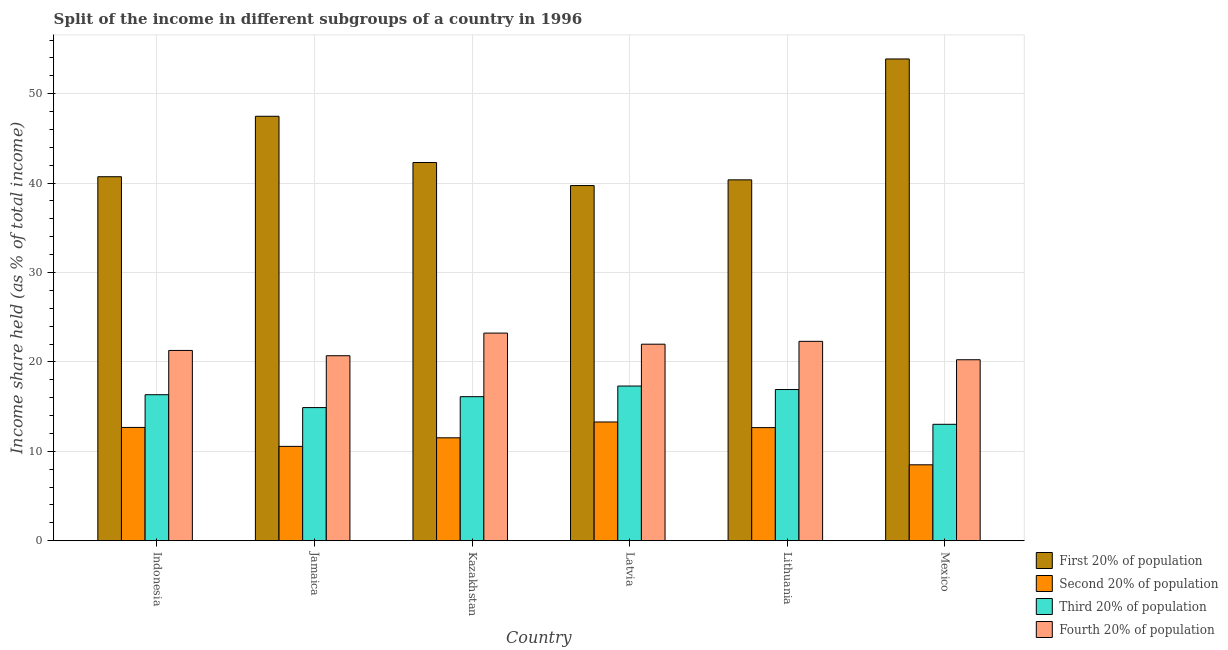How many different coloured bars are there?
Offer a very short reply. 4. Are the number of bars per tick equal to the number of legend labels?
Your response must be concise. Yes. Are the number of bars on each tick of the X-axis equal?
Give a very brief answer. Yes. How many bars are there on the 1st tick from the right?
Give a very brief answer. 4. What is the label of the 3rd group of bars from the left?
Your answer should be compact. Kazakhstan. In how many cases, is the number of bars for a given country not equal to the number of legend labels?
Your response must be concise. 0. What is the share of the income held by third 20% of the population in Indonesia?
Offer a very short reply. 16.33. Across all countries, what is the maximum share of the income held by fourth 20% of the population?
Your answer should be very brief. 23.22. Across all countries, what is the minimum share of the income held by second 20% of the population?
Keep it short and to the point. 8.49. In which country was the share of the income held by fourth 20% of the population maximum?
Ensure brevity in your answer.  Kazakhstan. In which country was the share of the income held by first 20% of the population minimum?
Make the answer very short. Latvia. What is the total share of the income held by fourth 20% of the population in the graph?
Offer a terse response. 129.71. What is the difference between the share of the income held by second 20% of the population in Kazakhstan and that in Mexico?
Your answer should be compact. 3.02. What is the difference between the share of the income held by first 20% of the population in Lithuania and the share of the income held by second 20% of the population in Jamaica?
Give a very brief answer. 29.81. What is the average share of the income held by first 20% of the population per country?
Provide a short and direct response. 44.07. What is the difference between the share of the income held by second 20% of the population and share of the income held by first 20% of the population in Lithuania?
Offer a very short reply. -27.71. In how many countries, is the share of the income held by first 20% of the population greater than 46 %?
Your answer should be compact. 2. What is the ratio of the share of the income held by third 20% of the population in Jamaica to that in Lithuania?
Ensure brevity in your answer.  0.88. What is the difference between the highest and the second highest share of the income held by second 20% of the population?
Make the answer very short. 0.61. What is the difference between the highest and the lowest share of the income held by first 20% of the population?
Your answer should be very brief. 14.16. In how many countries, is the share of the income held by fourth 20% of the population greater than the average share of the income held by fourth 20% of the population taken over all countries?
Your answer should be very brief. 3. Is the sum of the share of the income held by fourth 20% of the population in Latvia and Mexico greater than the maximum share of the income held by first 20% of the population across all countries?
Your response must be concise. No. Is it the case that in every country, the sum of the share of the income held by third 20% of the population and share of the income held by fourth 20% of the population is greater than the sum of share of the income held by first 20% of the population and share of the income held by second 20% of the population?
Ensure brevity in your answer.  No. What does the 1st bar from the left in Latvia represents?
Provide a short and direct response. First 20% of population. What does the 4th bar from the right in Jamaica represents?
Ensure brevity in your answer.  First 20% of population. Are all the bars in the graph horizontal?
Provide a succinct answer. No. How many countries are there in the graph?
Offer a very short reply. 6. What is the difference between two consecutive major ticks on the Y-axis?
Make the answer very short. 10. Are the values on the major ticks of Y-axis written in scientific E-notation?
Provide a succinct answer. No. Does the graph contain any zero values?
Keep it short and to the point. No. Where does the legend appear in the graph?
Offer a terse response. Bottom right. What is the title of the graph?
Your answer should be compact. Split of the income in different subgroups of a country in 1996. What is the label or title of the Y-axis?
Your answer should be very brief. Income share held (as % of total income). What is the Income share held (as % of total income) of First 20% of population in Indonesia?
Offer a very short reply. 40.71. What is the Income share held (as % of total income) of Second 20% of population in Indonesia?
Give a very brief answer. 12.67. What is the Income share held (as % of total income) of Third 20% of population in Indonesia?
Give a very brief answer. 16.33. What is the Income share held (as % of total income) in Fourth 20% of population in Indonesia?
Keep it short and to the point. 21.28. What is the Income share held (as % of total income) of First 20% of population in Jamaica?
Your response must be concise. 47.47. What is the Income share held (as % of total income) of Second 20% of population in Jamaica?
Your answer should be compact. 10.55. What is the Income share held (as % of total income) of Third 20% of population in Jamaica?
Provide a succinct answer. 14.89. What is the Income share held (as % of total income) of Fourth 20% of population in Jamaica?
Provide a short and direct response. 20.69. What is the Income share held (as % of total income) in First 20% of population in Kazakhstan?
Give a very brief answer. 42.3. What is the Income share held (as % of total income) in Second 20% of population in Kazakhstan?
Offer a terse response. 11.51. What is the Income share held (as % of total income) in Third 20% of population in Kazakhstan?
Your response must be concise. 16.11. What is the Income share held (as % of total income) in Fourth 20% of population in Kazakhstan?
Provide a short and direct response. 23.22. What is the Income share held (as % of total income) in First 20% of population in Latvia?
Your answer should be very brief. 39.72. What is the Income share held (as % of total income) in Second 20% of population in Latvia?
Offer a terse response. 13.28. What is the Income share held (as % of total income) of Third 20% of population in Latvia?
Give a very brief answer. 17.3. What is the Income share held (as % of total income) of Fourth 20% of population in Latvia?
Offer a terse response. 21.98. What is the Income share held (as % of total income) of First 20% of population in Lithuania?
Make the answer very short. 40.36. What is the Income share held (as % of total income) in Second 20% of population in Lithuania?
Ensure brevity in your answer.  12.65. What is the Income share held (as % of total income) of Third 20% of population in Lithuania?
Offer a terse response. 16.91. What is the Income share held (as % of total income) in Fourth 20% of population in Lithuania?
Offer a very short reply. 22.3. What is the Income share held (as % of total income) of First 20% of population in Mexico?
Your response must be concise. 53.88. What is the Income share held (as % of total income) in Second 20% of population in Mexico?
Your answer should be very brief. 8.49. What is the Income share held (as % of total income) in Third 20% of population in Mexico?
Provide a short and direct response. 13.02. What is the Income share held (as % of total income) of Fourth 20% of population in Mexico?
Provide a succinct answer. 20.24. Across all countries, what is the maximum Income share held (as % of total income) of First 20% of population?
Make the answer very short. 53.88. Across all countries, what is the maximum Income share held (as % of total income) in Second 20% of population?
Your response must be concise. 13.28. Across all countries, what is the maximum Income share held (as % of total income) in Fourth 20% of population?
Offer a very short reply. 23.22. Across all countries, what is the minimum Income share held (as % of total income) in First 20% of population?
Make the answer very short. 39.72. Across all countries, what is the minimum Income share held (as % of total income) of Second 20% of population?
Offer a very short reply. 8.49. Across all countries, what is the minimum Income share held (as % of total income) of Third 20% of population?
Your response must be concise. 13.02. Across all countries, what is the minimum Income share held (as % of total income) of Fourth 20% of population?
Your response must be concise. 20.24. What is the total Income share held (as % of total income) in First 20% of population in the graph?
Your answer should be compact. 264.44. What is the total Income share held (as % of total income) in Second 20% of population in the graph?
Keep it short and to the point. 69.15. What is the total Income share held (as % of total income) in Third 20% of population in the graph?
Make the answer very short. 94.56. What is the total Income share held (as % of total income) of Fourth 20% of population in the graph?
Your answer should be compact. 129.71. What is the difference between the Income share held (as % of total income) in First 20% of population in Indonesia and that in Jamaica?
Provide a succinct answer. -6.76. What is the difference between the Income share held (as % of total income) in Second 20% of population in Indonesia and that in Jamaica?
Ensure brevity in your answer.  2.12. What is the difference between the Income share held (as % of total income) of Third 20% of population in Indonesia and that in Jamaica?
Offer a very short reply. 1.44. What is the difference between the Income share held (as % of total income) in Fourth 20% of population in Indonesia and that in Jamaica?
Keep it short and to the point. 0.59. What is the difference between the Income share held (as % of total income) in First 20% of population in Indonesia and that in Kazakhstan?
Provide a short and direct response. -1.59. What is the difference between the Income share held (as % of total income) of Second 20% of population in Indonesia and that in Kazakhstan?
Your response must be concise. 1.16. What is the difference between the Income share held (as % of total income) of Third 20% of population in Indonesia and that in Kazakhstan?
Offer a terse response. 0.22. What is the difference between the Income share held (as % of total income) of Fourth 20% of population in Indonesia and that in Kazakhstan?
Provide a succinct answer. -1.94. What is the difference between the Income share held (as % of total income) in First 20% of population in Indonesia and that in Latvia?
Offer a terse response. 0.99. What is the difference between the Income share held (as % of total income) in Second 20% of population in Indonesia and that in Latvia?
Keep it short and to the point. -0.61. What is the difference between the Income share held (as % of total income) of Third 20% of population in Indonesia and that in Latvia?
Offer a very short reply. -0.97. What is the difference between the Income share held (as % of total income) of Fourth 20% of population in Indonesia and that in Latvia?
Your answer should be very brief. -0.7. What is the difference between the Income share held (as % of total income) of First 20% of population in Indonesia and that in Lithuania?
Offer a very short reply. 0.35. What is the difference between the Income share held (as % of total income) in Second 20% of population in Indonesia and that in Lithuania?
Your response must be concise. 0.02. What is the difference between the Income share held (as % of total income) of Third 20% of population in Indonesia and that in Lithuania?
Offer a very short reply. -0.58. What is the difference between the Income share held (as % of total income) in Fourth 20% of population in Indonesia and that in Lithuania?
Provide a succinct answer. -1.02. What is the difference between the Income share held (as % of total income) in First 20% of population in Indonesia and that in Mexico?
Your response must be concise. -13.17. What is the difference between the Income share held (as % of total income) of Second 20% of population in Indonesia and that in Mexico?
Offer a very short reply. 4.18. What is the difference between the Income share held (as % of total income) in Third 20% of population in Indonesia and that in Mexico?
Make the answer very short. 3.31. What is the difference between the Income share held (as % of total income) in Fourth 20% of population in Indonesia and that in Mexico?
Ensure brevity in your answer.  1.04. What is the difference between the Income share held (as % of total income) of First 20% of population in Jamaica and that in Kazakhstan?
Your answer should be compact. 5.17. What is the difference between the Income share held (as % of total income) of Second 20% of population in Jamaica and that in Kazakhstan?
Keep it short and to the point. -0.96. What is the difference between the Income share held (as % of total income) of Third 20% of population in Jamaica and that in Kazakhstan?
Your answer should be very brief. -1.22. What is the difference between the Income share held (as % of total income) in Fourth 20% of population in Jamaica and that in Kazakhstan?
Make the answer very short. -2.53. What is the difference between the Income share held (as % of total income) of First 20% of population in Jamaica and that in Latvia?
Provide a succinct answer. 7.75. What is the difference between the Income share held (as % of total income) of Second 20% of population in Jamaica and that in Latvia?
Offer a terse response. -2.73. What is the difference between the Income share held (as % of total income) of Third 20% of population in Jamaica and that in Latvia?
Your answer should be very brief. -2.41. What is the difference between the Income share held (as % of total income) of Fourth 20% of population in Jamaica and that in Latvia?
Offer a very short reply. -1.29. What is the difference between the Income share held (as % of total income) in First 20% of population in Jamaica and that in Lithuania?
Your answer should be compact. 7.11. What is the difference between the Income share held (as % of total income) in Third 20% of population in Jamaica and that in Lithuania?
Your answer should be very brief. -2.02. What is the difference between the Income share held (as % of total income) of Fourth 20% of population in Jamaica and that in Lithuania?
Make the answer very short. -1.61. What is the difference between the Income share held (as % of total income) of First 20% of population in Jamaica and that in Mexico?
Make the answer very short. -6.41. What is the difference between the Income share held (as % of total income) in Second 20% of population in Jamaica and that in Mexico?
Give a very brief answer. 2.06. What is the difference between the Income share held (as % of total income) of Third 20% of population in Jamaica and that in Mexico?
Your answer should be very brief. 1.87. What is the difference between the Income share held (as % of total income) in Fourth 20% of population in Jamaica and that in Mexico?
Offer a very short reply. 0.45. What is the difference between the Income share held (as % of total income) in First 20% of population in Kazakhstan and that in Latvia?
Keep it short and to the point. 2.58. What is the difference between the Income share held (as % of total income) in Second 20% of population in Kazakhstan and that in Latvia?
Keep it short and to the point. -1.77. What is the difference between the Income share held (as % of total income) in Third 20% of population in Kazakhstan and that in Latvia?
Offer a very short reply. -1.19. What is the difference between the Income share held (as % of total income) of Fourth 20% of population in Kazakhstan and that in Latvia?
Offer a terse response. 1.24. What is the difference between the Income share held (as % of total income) in First 20% of population in Kazakhstan and that in Lithuania?
Give a very brief answer. 1.94. What is the difference between the Income share held (as % of total income) in Second 20% of population in Kazakhstan and that in Lithuania?
Give a very brief answer. -1.14. What is the difference between the Income share held (as % of total income) in Fourth 20% of population in Kazakhstan and that in Lithuania?
Ensure brevity in your answer.  0.92. What is the difference between the Income share held (as % of total income) of First 20% of population in Kazakhstan and that in Mexico?
Keep it short and to the point. -11.58. What is the difference between the Income share held (as % of total income) in Second 20% of population in Kazakhstan and that in Mexico?
Give a very brief answer. 3.02. What is the difference between the Income share held (as % of total income) in Third 20% of population in Kazakhstan and that in Mexico?
Give a very brief answer. 3.09. What is the difference between the Income share held (as % of total income) in Fourth 20% of population in Kazakhstan and that in Mexico?
Make the answer very short. 2.98. What is the difference between the Income share held (as % of total income) of First 20% of population in Latvia and that in Lithuania?
Your response must be concise. -0.64. What is the difference between the Income share held (as % of total income) of Second 20% of population in Latvia and that in Lithuania?
Make the answer very short. 0.63. What is the difference between the Income share held (as % of total income) of Third 20% of population in Latvia and that in Lithuania?
Provide a succinct answer. 0.39. What is the difference between the Income share held (as % of total income) of Fourth 20% of population in Latvia and that in Lithuania?
Ensure brevity in your answer.  -0.32. What is the difference between the Income share held (as % of total income) in First 20% of population in Latvia and that in Mexico?
Your answer should be compact. -14.16. What is the difference between the Income share held (as % of total income) of Second 20% of population in Latvia and that in Mexico?
Your answer should be very brief. 4.79. What is the difference between the Income share held (as % of total income) in Third 20% of population in Latvia and that in Mexico?
Offer a terse response. 4.28. What is the difference between the Income share held (as % of total income) in Fourth 20% of population in Latvia and that in Mexico?
Offer a very short reply. 1.74. What is the difference between the Income share held (as % of total income) in First 20% of population in Lithuania and that in Mexico?
Your response must be concise. -13.52. What is the difference between the Income share held (as % of total income) in Second 20% of population in Lithuania and that in Mexico?
Give a very brief answer. 4.16. What is the difference between the Income share held (as % of total income) in Third 20% of population in Lithuania and that in Mexico?
Your answer should be very brief. 3.89. What is the difference between the Income share held (as % of total income) of Fourth 20% of population in Lithuania and that in Mexico?
Ensure brevity in your answer.  2.06. What is the difference between the Income share held (as % of total income) in First 20% of population in Indonesia and the Income share held (as % of total income) in Second 20% of population in Jamaica?
Ensure brevity in your answer.  30.16. What is the difference between the Income share held (as % of total income) of First 20% of population in Indonesia and the Income share held (as % of total income) of Third 20% of population in Jamaica?
Keep it short and to the point. 25.82. What is the difference between the Income share held (as % of total income) of First 20% of population in Indonesia and the Income share held (as % of total income) of Fourth 20% of population in Jamaica?
Ensure brevity in your answer.  20.02. What is the difference between the Income share held (as % of total income) in Second 20% of population in Indonesia and the Income share held (as % of total income) in Third 20% of population in Jamaica?
Your answer should be compact. -2.22. What is the difference between the Income share held (as % of total income) in Second 20% of population in Indonesia and the Income share held (as % of total income) in Fourth 20% of population in Jamaica?
Your response must be concise. -8.02. What is the difference between the Income share held (as % of total income) of Third 20% of population in Indonesia and the Income share held (as % of total income) of Fourth 20% of population in Jamaica?
Your answer should be very brief. -4.36. What is the difference between the Income share held (as % of total income) of First 20% of population in Indonesia and the Income share held (as % of total income) of Second 20% of population in Kazakhstan?
Your answer should be compact. 29.2. What is the difference between the Income share held (as % of total income) of First 20% of population in Indonesia and the Income share held (as % of total income) of Third 20% of population in Kazakhstan?
Offer a very short reply. 24.6. What is the difference between the Income share held (as % of total income) of First 20% of population in Indonesia and the Income share held (as % of total income) of Fourth 20% of population in Kazakhstan?
Give a very brief answer. 17.49. What is the difference between the Income share held (as % of total income) in Second 20% of population in Indonesia and the Income share held (as % of total income) in Third 20% of population in Kazakhstan?
Make the answer very short. -3.44. What is the difference between the Income share held (as % of total income) in Second 20% of population in Indonesia and the Income share held (as % of total income) in Fourth 20% of population in Kazakhstan?
Keep it short and to the point. -10.55. What is the difference between the Income share held (as % of total income) of Third 20% of population in Indonesia and the Income share held (as % of total income) of Fourth 20% of population in Kazakhstan?
Provide a short and direct response. -6.89. What is the difference between the Income share held (as % of total income) of First 20% of population in Indonesia and the Income share held (as % of total income) of Second 20% of population in Latvia?
Ensure brevity in your answer.  27.43. What is the difference between the Income share held (as % of total income) of First 20% of population in Indonesia and the Income share held (as % of total income) of Third 20% of population in Latvia?
Your answer should be very brief. 23.41. What is the difference between the Income share held (as % of total income) in First 20% of population in Indonesia and the Income share held (as % of total income) in Fourth 20% of population in Latvia?
Ensure brevity in your answer.  18.73. What is the difference between the Income share held (as % of total income) of Second 20% of population in Indonesia and the Income share held (as % of total income) of Third 20% of population in Latvia?
Your answer should be compact. -4.63. What is the difference between the Income share held (as % of total income) of Second 20% of population in Indonesia and the Income share held (as % of total income) of Fourth 20% of population in Latvia?
Your response must be concise. -9.31. What is the difference between the Income share held (as % of total income) in Third 20% of population in Indonesia and the Income share held (as % of total income) in Fourth 20% of population in Latvia?
Ensure brevity in your answer.  -5.65. What is the difference between the Income share held (as % of total income) in First 20% of population in Indonesia and the Income share held (as % of total income) in Second 20% of population in Lithuania?
Your answer should be compact. 28.06. What is the difference between the Income share held (as % of total income) of First 20% of population in Indonesia and the Income share held (as % of total income) of Third 20% of population in Lithuania?
Provide a succinct answer. 23.8. What is the difference between the Income share held (as % of total income) of First 20% of population in Indonesia and the Income share held (as % of total income) of Fourth 20% of population in Lithuania?
Your response must be concise. 18.41. What is the difference between the Income share held (as % of total income) in Second 20% of population in Indonesia and the Income share held (as % of total income) in Third 20% of population in Lithuania?
Provide a short and direct response. -4.24. What is the difference between the Income share held (as % of total income) in Second 20% of population in Indonesia and the Income share held (as % of total income) in Fourth 20% of population in Lithuania?
Provide a succinct answer. -9.63. What is the difference between the Income share held (as % of total income) in Third 20% of population in Indonesia and the Income share held (as % of total income) in Fourth 20% of population in Lithuania?
Give a very brief answer. -5.97. What is the difference between the Income share held (as % of total income) of First 20% of population in Indonesia and the Income share held (as % of total income) of Second 20% of population in Mexico?
Offer a terse response. 32.22. What is the difference between the Income share held (as % of total income) of First 20% of population in Indonesia and the Income share held (as % of total income) of Third 20% of population in Mexico?
Provide a short and direct response. 27.69. What is the difference between the Income share held (as % of total income) of First 20% of population in Indonesia and the Income share held (as % of total income) of Fourth 20% of population in Mexico?
Your response must be concise. 20.47. What is the difference between the Income share held (as % of total income) in Second 20% of population in Indonesia and the Income share held (as % of total income) in Third 20% of population in Mexico?
Keep it short and to the point. -0.35. What is the difference between the Income share held (as % of total income) of Second 20% of population in Indonesia and the Income share held (as % of total income) of Fourth 20% of population in Mexico?
Offer a very short reply. -7.57. What is the difference between the Income share held (as % of total income) of Third 20% of population in Indonesia and the Income share held (as % of total income) of Fourth 20% of population in Mexico?
Your answer should be very brief. -3.91. What is the difference between the Income share held (as % of total income) of First 20% of population in Jamaica and the Income share held (as % of total income) of Second 20% of population in Kazakhstan?
Give a very brief answer. 35.96. What is the difference between the Income share held (as % of total income) of First 20% of population in Jamaica and the Income share held (as % of total income) of Third 20% of population in Kazakhstan?
Ensure brevity in your answer.  31.36. What is the difference between the Income share held (as % of total income) of First 20% of population in Jamaica and the Income share held (as % of total income) of Fourth 20% of population in Kazakhstan?
Offer a very short reply. 24.25. What is the difference between the Income share held (as % of total income) in Second 20% of population in Jamaica and the Income share held (as % of total income) in Third 20% of population in Kazakhstan?
Keep it short and to the point. -5.56. What is the difference between the Income share held (as % of total income) in Second 20% of population in Jamaica and the Income share held (as % of total income) in Fourth 20% of population in Kazakhstan?
Provide a succinct answer. -12.67. What is the difference between the Income share held (as % of total income) of Third 20% of population in Jamaica and the Income share held (as % of total income) of Fourth 20% of population in Kazakhstan?
Give a very brief answer. -8.33. What is the difference between the Income share held (as % of total income) of First 20% of population in Jamaica and the Income share held (as % of total income) of Second 20% of population in Latvia?
Make the answer very short. 34.19. What is the difference between the Income share held (as % of total income) in First 20% of population in Jamaica and the Income share held (as % of total income) in Third 20% of population in Latvia?
Your response must be concise. 30.17. What is the difference between the Income share held (as % of total income) in First 20% of population in Jamaica and the Income share held (as % of total income) in Fourth 20% of population in Latvia?
Offer a very short reply. 25.49. What is the difference between the Income share held (as % of total income) of Second 20% of population in Jamaica and the Income share held (as % of total income) of Third 20% of population in Latvia?
Ensure brevity in your answer.  -6.75. What is the difference between the Income share held (as % of total income) in Second 20% of population in Jamaica and the Income share held (as % of total income) in Fourth 20% of population in Latvia?
Give a very brief answer. -11.43. What is the difference between the Income share held (as % of total income) in Third 20% of population in Jamaica and the Income share held (as % of total income) in Fourth 20% of population in Latvia?
Your answer should be very brief. -7.09. What is the difference between the Income share held (as % of total income) of First 20% of population in Jamaica and the Income share held (as % of total income) of Second 20% of population in Lithuania?
Offer a terse response. 34.82. What is the difference between the Income share held (as % of total income) in First 20% of population in Jamaica and the Income share held (as % of total income) in Third 20% of population in Lithuania?
Make the answer very short. 30.56. What is the difference between the Income share held (as % of total income) of First 20% of population in Jamaica and the Income share held (as % of total income) of Fourth 20% of population in Lithuania?
Provide a short and direct response. 25.17. What is the difference between the Income share held (as % of total income) in Second 20% of population in Jamaica and the Income share held (as % of total income) in Third 20% of population in Lithuania?
Keep it short and to the point. -6.36. What is the difference between the Income share held (as % of total income) of Second 20% of population in Jamaica and the Income share held (as % of total income) of Fourth 20% of population in Lithuania?
Make the answer very short. -11.75. What is the difference between the Income share held (as % of total income) of Third 20% of population in Jamaica and the Income share held (as % of total income) of Fourth 20% of population in Lithuania?
Offer a very short reply. -7.41. What is the difference between the Income share held (as % of total income) of First 20% of population in Jamaica and the Income share held (as % of total income) of Second 20% of population in Mexico?
Give a very brief answer. 38.98. What is the difference between the Income share held (as % of total income) of First 20% of population in Jamaica and the Income share held (as % of total income) of Third 20% of population in Mexico?
Ensure brevity in your answer.  34.45. What is the difference between the Income share held (as % of total income) of First 20% of population in Jamaica and the Income share held (as % of total income) of Fourth 20% of population in Mexico?
Provide a succinct answer. 27.23. What is the difference between the Income share held (as % of total income) of Second 20% of population in Jamaica and the Income share held (as % of total income) of Third 20% of population in Mexico?
Make the answer very short. -2.47. What is the difference between the Income share held (as % of total income) in Second 20% of population in Jamaica and the Income share held (as % of total income) in Fourth 20% of population in Mexico?
Provide a succinct answer. -9.69. What is the difference between the Income share held (as % of total income) of Third 20% of population in Jamaica and the Income share held (as % of total income) of Fourth 20% of population in Mexico?
Your response must be concise. -5.35. What is the difference between the Income share held (as % of total income) of First 20% of population in Kazakhstan and the Income share held (as % of total income) of Second 20% of population in Latvia?
Offer a terse response. 29.02. What is the difference between the Income share held (as % of total income) of First 20% of population in Kazakhstan and the Income share held (as % of total income) of Third 20% of population in Latvia?
Provide a short and direct response. 25. What is the difference between the Income share held (as % of total income) of First 20% of population in Kazakhstan and the Income share held (as % of total income) of Fourth 20% of population in Latvia?
Your response must be concise. 20.32. What is the difference between the Income share held (as % of total income) of Second 20% of population in Kazakhstan and the Income share held (as % of total income) of Third 20% of population in Latvia?
Offer a terse response. -5.79. What is the difference between the Income share held (as % of total income) in Second 20% of population in Kazakhstan and the Income share held (as % of total income) in Fourth 20% of population in Latvia?
Give a very brief answer. -10.47. What is the difference between the Income share held (as % of total income) of Third 20% of population in Kazakhstan and the Income share held (as % of total income) of Fourth 20% of population in Latvia?
Your answer should be compact. -5.87. What is the difference between the Income share held (as % of total income) of First 20% of population in Kazakhstan and the Income share held (as % of total income) of Second 20% of population in Lithuania?
Your response must be concise. 29.65. What is the difference between the Income share held (as % of total income) of First 20% of population in Kazakhstan and the Income share held (as % of total income) of Third 20% of population in Lithuania?
Your response must be concise. 25.39. What is the difference between the Income share held (as % of total income) in First 20% of population in Kazakhstan and the Income share held (as % of total income) in Fourth 20% of population in Lithuania?
Keep it short and to the point. 20. What is the difference between the Income share held (as % of total income) of Second 20% of population in Kazakhstan and the Income share held (as % of total income) of Third 20% of population in Lithuania?
Give a very brief answer. -5.4. What is the difference between the Income share held (as % of total income) of Second 20% of population in Kazakhstan and the Income share held (as % of total income) of Fourth 20% of population in Lithuania?
Your answer should be compact. -10.79. What is the difference between the Income share held (as % of total income) of Third 20% of population in Kazakhstan and the Income share held (as % of total income) of Fourth 20% of population in Lithuania?
Give a very brief answer. -6.19. What is the difference between the Income share held (as % of total income) of First 20% of population in Kazakhstan and the Income share held (as % of total income) of Second 20% of population in Mexico?
Your answer should be very brief. 33.81. What is the difference between the Income share held (as % of total income) in First 20% of population in Kazakhstan and the Income share held (as % of total income) in Third 20% of population in Mexico?
Your answer should be very brief. 29.28. What is the difference between the Income share held (as % of total income) of First 20% of population in Kazakhstan and the Income share held (as % of total income) of Fourth 20% of population in Mexico?
Offer a terse response. 22.06. What is the difference between the Income share held (as % of total income) in Second 20% of population in Kazakhstan and the Income share held (as % of total income) in Third 20% of population in Mexico?
Provide a succinct answer. -1.51. What is the difference between the Income share held (as % of total income) of Second 20% of population in Kazakhstan and the Income share held (as % of total income) of Fourth 20% of population in Mexico?
Give a very brief answer. -8.73. What is the difference between the Income share held (as % of total income) of Third 20% of population in Kazakhstan and the Income share held (as % of total income) of Fourth 20% of population in Mexico?
Offer a very short reply. -4.13. What is the difference between the Income share held (as % of total income) of First 20% of population in Latvia and the Income share held (as % of total income) of Second 20% of population in Lithuania?
Keep it short and to the point. 27.07. What is the difference between the Income share held (as % of total income) of First 20% of population in Latvia and the Income share held (as % of total income) of Third 20% of population in Lithuania?
Offer a very short reply. 22.81. What is the difference between the Income share held (as % of total income) of First 20% of population in Latvia and the Income share held (as % of total income) of Fourth 20% of population in Lithuania?
Your answer should be compact. 17.42. What is the difference between the Income share held (as % of total income) of Second 20% of population in Latvia and the Income share held (as % of total income) of Third 20% of population in Lithuania?
Your answer should be compact. -3.63. What is the difference between the Income share held (as % of total income) in Second 20% of population in Latvia and the Income share held (as % of total income) in Fourth 20% of population in Lithuania?
Ensure brevity in your answer.  -9.02. What is the difference between the Income share held (as % of total income) of Third 20% of population in Latvia and the Income share held (as % of total income) of Fourth 20% of population in Lithuania?
Your response must be concise. -5. What is the difference between the Income share held (as % of total income) of First 20% of population in Latvia and the Income share held (as % of total income) of Second 20% of population in Mexico?
Keep it short and to the point. 31.23. What is the difference between the Income share held (as % of total income) of First 20% of population in Latvia and the Income share held (as % of total income) of Third 20% of population in Mexico?
Make the answer very short. 26.7. What is the difference between the Income share held (as % of total income) in First 20% of population in Latvia and the Income share held (as % of total income) in Fourth 20% of population in Mexico?
Provide a short and direct response. 19.48. What is the difference between the Income share held (as % of total income) in Second 20% of population in Latvia and the Income share held (as % of total income) in Third 20% of population in Mexico?
Give a very brief answer. 0.26. What is the difference between the Income share held (as % of total income) of Second 20% of population in Latvia and the Income share held (as % of total income) of Fourth 20% of population in Mexico?
Make the answer very short. -6.96. What is the difference between the Income share held (as % of total income) in Third 20% of population in Latvia and the Income share held (as % of total income) in Fourth 20% of population in Mexico?
Offer a very short reply. -2.94. What is the difference between the Income share held (as % of total income) of First 20% of population in Lithuania and the Income share held (as % of total income) of Second 20% of population in Mexico?
Provide a short and direct response. 31.87. What is the difference between the Income share held (as % of total income) in First 20% of population in Lithuania and the Income share held (as % of total income) in Third 20% of population in Mexico?
Make the answer very short. 27.34. What is the difference between the Income share held (as % of total income) in First 20% of population in Lithuania and the Income share held (as % of total income) in Fourth 20% of population in Mexico?
Provide a succinct answer. 20.12. What is the difference between the Income share held (as % of total income) of Second 20% of population in Lithuania and the Income share held (as % of total income) of Third 20% of population in Mexico?
Keep it short and to the point. -0.37. What is the difference between the Income share held (as % of total income) of Second 20% of population in Lithuania and the Income share held (as % of total income) of Fourth 20% of population in Mexico?
Your answer should be very brief. -7.59. What is the difference between the Income share held (as % of total income) of Third 20% of population in Lithuania and the Income share held (as % of total income) of Fourth 20% of population in Mexico?
Your response must be concise. -3.33. What is the average Income share held (as % of total income) in First 20% of population per country?
Provide a short and direct response. 44.07. What is the average Income share held (as % of total income) of Second 20% of population per country?
Make the answer very short. 11.53. What is the average Income share held (as % of total income) of Third 20% of population per country?
Your answer should be very brief. 15.76. What is the average Income share held (as % of total income) in Fourth 20% of population per country?
Make the answer very short. 21.62. What is the difference between the Income share held (as % of total income) of First 20% of population and Income share held (as % of total income) of Second 20% of population in Indonesia?
Your answer should be compact. 28.04. What is the difference between the Income share held (as % of total income) of First 20% of population and Income share held (as % of total income) of Third 20% of population in Indonesia?
Your response must be concise. 24.38. What is the difference between the Income share held (as % of total income) of First 20% of population and Income share held (as % of total income) of Fourth 20% of population in Indonesia?
Give a very brief answer. 19.43. What is the difference between the Income share held (as % of total income) in Second 20% of population and Income share held (as % of total income) in Third 20% of population in Indonesia?
Ensure brevity in your answer.  -3.66. What is the difference between the Income share held (as % of total income) of Second 20% of population and Income share held (as % of total income) of Fourth 20% of population in Indonesia?
Your answer should be very brief. -8.61. What is the difference between the Income share held (as % of total income) in Third 20% of population and Income share held (as % of total income) in Fourth 20% of population in Indonesia?
Offer a very short reply. -4.95. What is the difference between the Income share held (as % of total income) of First 20% of population and Income share held (as % of total income) of Second 20% of population in Jamaica?
Ensure brevity in your answer.  36.92. What is the difference between the Income share held (as % of total income) of First 20% of population and Income share held (as % of total income) of Third 20% of population in Jamaica?
Provide a succinct answer. 32.58. What is the difference between the Income share held (as % of total income) in First 20% of population and Income share held (as % of total income) in Fourth 20% of population in Jamaica?
Your response must be concise. 26.78. What is the difference between the Income share held (as % of total income) in Second 20% of population and Income share held (as % of total income) in Third 20% of population in Jamaica?
Your answer should be compact. -4.34. What is the difference between the Income share held (as % of total income) of Second 20% of population and Income share held (as % of total income) of Fourth 20% of population in Jamaica?
Make the answer very short. -10.14. What is the difference between the Income share held (as % of total income) in First 20% of population and Income share held (as % of total income) in Second 20% of population in Kazakhstan?
Keep it short and to the point. 30.79. What is the difference between the Income share held (as % of total income) in First 20% of population and Income share held (as % of total income) in Third 20% of population in Kazakhstan?
Keep it short and to the point. 26.19. What is the difference between the Income share held (as % of total income) in First 20% of population and Income share held (as % of total income) in Fourth 20% of population in Kazakhstan?
Provide a succinct answer. 19.08. What is the difference between the Income share held (as % of total income) of Second 20% of population and Income share held (as % of total income) of Fourth 20% of population in Kazakhstan?
Your answer should be very brief. -11.71. What is the difference between the Income share held (as % of total income) of Third 20% of population and Income share held (as % of total income) of Fourth 20% of population in Kazakhstan?
Your response must be concise. -7.11. What is the difference between the Income share held (as % of total income) in First 20% of population and Income share held (as % of total income) in Second 20% of population in Latvia?
Provide a succinct answer. 26.44. What is the difference between the Income share held (as % of total income) in First 20% of population and Income share held (as % of total income) in Third 20% of population in Latvia?
Your response must be concise. 22.42. What is the difference between the Income share held (as % of total income) in First 20% of population and Income share held (as % of total income) in Fourth 20% of population in Latvia?
Your response must be concise. 17.74. What is the difference between the Income share held (as % of total income) in Second 20% of population and Income share held (as % of total income) in Third 20% of population in Latvia?
Your response must be concise. -4.02. What is the difference between the Income share held (as % of total income) in Third 20% of population and Income share held (as % of total income) in Fourth 20% of population in Latvia?
Ensure brevity in your answer.  -4.68. What is the difference between the Income share held (as % of total income) in First 20% of population and Income share held (as % of total income) in Second 20% of population in Lithuania?
Ensure brevity in your answer.  27.71. What is the difference between the Income share held (as % of total income) of First 20% of population and Income share held (as % of total income) of Third 20% of population in Lithuania?
Ensure brevity in your answer.  23.45. What is the difference between the Income share held (as % of total income) of First 20% of population and Income share held (as % of total income) of Fourth 20% of population in Lithuania?
Your answer should be very brief. 18.06. What is the difference between the Income share held (as % of total income) of Second 20% of population and Income share held (as % of total income) of Third 20% of population in Lithuania?
Your answer should be compact. -4.26. What is the difference between the Income share held (as % of total income) in Second 20% of population and Income share held (as % of total income) in Fourth 20% of population in Lithuania?
Give a very brief answer. -9.65. What is the difference between the Income share held (as % of total income) of Third 20% of population and Income share held (as % of total income) of Fourth 20% of population in Lithuania?
Provide a succinct answer. -5.39. What is the difference between the Income share held (as % of total income) in First 20% of population and Income share held (as % of total income) in Second 20% of population in Mexico?
Your answer should be compact. 45.39. What is the difference between the Income share held (as % of total income) of First 20% of population and Income share held (as % of total income) of Third 20% of population in Mexico?
Provide a short and direct response. 40.86. What is the difference between the Income share held (as % of total income) of First 20% of population and Income share held (as % of total income) of Fourth 20% of population in Mexico?
Make the answer very short. 33.64. What is the difference between the Income share held (as % of total income) of Second 20% of population and Income share held (as % of total income) of Third 20% of population in Mexico?
Provide a succinct answer. -4.53. What is the difference between the Income share held (as % of total income) of Second 20% of population and Income share held (as % of total income) of Fourth 20% of population in Mexico?
Provide a succinct answer. -11.75. What is the difference between the Income share held (as % of total income) of Third 20% of population and Income share held (as % of total income) of Fourth 20% of population in Mexico?
Offer a very short reply. -7.22. What is the ratio of the Income share held (as % of total income) in First 20% of population in Indonesia to that in Jamaica?
Your response must be concise. 0.86. What is the ratio of the Income share held (as % of total income) in Second 20% of population in Indonesia to that in Jamaica?
Give a very brief answer. 1.2. What is the ratio of the Income share held (as % of total income) of Third 20% of population in Indonesia to that in Jamaica?
Keep it short and to the point. 1.1. What is the ratio of the Income share held (as % of total income) in Fourth 20% of population in Indonesia to that in Jamaica?
Provide a succinct answer. 1.03. What is the ratio of the Income share held (as % of total income) of First 20% of population in Indonesia to that in Kazakhstan?
Give a very brief answer. 0.96. What is the ratio of the Income share held (as % of total income) of Second 20% of population in Indonesia to that in Kazakhstan?
Your answer should be compact. 1.1. What is the ratio of the Income share held (as % of total income) of Third 20% of population in Indonesia to that in Kazakhstan?
Ensure brevity in your answer.  1.01. What is the ratio of the Income share held (as % of total income) in Fourth 20% of population in Indonesia to that in Kazakhstan?
Provide a short and direct response. 0.92. What is the ratio of the Income share held (as % of total income) of First 20% of population in Indonesia to that in Latvia?
Give a very brief answer. 1.02. What is the ratio of the Income share held (as % of total income) in Second 20% of population in Indonesia to that in Latvia?
Ensure brevity in your answer.  0.95. What is the ratio of the Income share held (as % of total income) in Third 20% of population in Indonesia to that in Latvia?
Offer a very short reply. 0.94. What is the ratio of the Income share held (as % of total income) in Fourth 20% of population in Indonesia to that in Latvia?
Your response must be concise. 0.97. What is the ratio of the Income share held (as % of total income) of First 20% of population in Indonesia to that in Lithuania?
Make the answer very short. 1.01. What is the ratio of the Income share held (as % of total income) in Third 20% of population in Indonesia to that in Lithuania?
Give a very brief answer. 0.97. What is the ratio of the Income share held (as % of total income) of Fourth 20% of population in Indonesia to that in Lithuania?
Provide a short and direct response. 0.95. What is the ratio of the Income share held (as % of total income) of First 20% of population in Indonesia to that in Mexico?
Provide a short and direct response. 0.76. What is the ratio of the Income share held (as % of total income) in Second 20% of population in Indonesia to that in Mexico?
Make the answer very short. 1.49. What is the ratio of the Income share held (as % of total income) in Third 20% of population in Indonesia to that in Mexico?
Make the answer very short. 1.25. What is the ratio of the Income share held (as % of total income) in Fourth 20% of population in Indonesia to that in Mexico?
Offer a terse response. 1.05. What is the ratio of the Income share held (as % of total income) of First 20% of population in Jamaica to that in Kazakhstan?
Keep it short and to the point. 1.12. What is the ratio of the Income share held (as % of total income) of Second 20% of population in Jamaica to that in Kazakhstan?
Give a very brief answer. 0.92. What is the ratio of the Income share held (as % of total income) in Third 20% of population in Jamaica to that in Kazakhstan?
Your answer should be very brief. 0.92. What is the ratio of the Income share held (as % of total income) in Fourth 20% of population in Jamaica to that in Kazakhstan?
Your answer should be very brief. 0.89. What is the ratio of the Income share held (as % of total income) of First 20% of population in Jamaica to that in Latvia?
Your answer should be compact. 1.2. What is the ratio of the Income share held (as % of total income) in Second 20% of population in Jamaica to that in Latvia?
Offer a very short reply. 0.79. What is the ratio of the Income share held (as % of total income) of Third 20% of population in Jamaica to that in Latvia?
Your response must be concise. 0.86. What is the ratio of the Income share held (as % of total income) in Fourth 20% of population in Jamaica to that in Latvia?
Give a very brief answer. 0.94. What is the ratio of the Income share held (as % of total income) in First 20% of population in Jamaica to that in Lithuania?
Keep it short and to the point. 1.18. What is the ratio of the Income share held (as % of total income) in Second 20% of population in Jamaica to that in Lithuania?
Your response must be concise. 0.83. What is the ratio of the Income share held (as % of total income) in Third 20% of population in Jamaica to that in Lithuania?
Provide a succinct answer. 0.88. What is the ratio of the Income share held (as % of total income) in Fourth 20% of population in Jamaica to that in Lithuania?
Your response must be concise. 0.93. What is the ratio of the Income share held (as % of total income) in First 20% of population in Jamaica to that in Mexico?
Offer a terse response. 0.88. What is the ratio of the Income share held (as % of total income) in Second 20% of population in Jamaica to that in Mexico?
Your answer should be very brief. 1.24. What is the ratio of the Income share held (as % of total income) of Third 20% of population in Jamaica to that in Mexico?
Give a very brief answer. 1.14. What is the ratio of the Income share held (as % of total income) in Fourth 20% of population in Jamaica to that in Mexico?
Provide a short and direct response. 1.02. What is the ratio of the Income share held (as % of total income) in First 20% of population in Kazakhstan to that in Latvia?
Your response must be concise. 1.06. What is the ratio of the Income share held (as % of total income) of Second 20% of population in Kazakhstan to that in Latvia?
Ensure brevity in your answer.  0.87. What is the ratio of the Income share held (as % of total income) of Third 20% of population in Kazakhstan to that in Latvia?
Your response must be concise. 0.93. What is the ratio of the Income share held (as % of total income) in Fourth 20% of population in Kazakhstan to that in Latvia?
Keep it short and to the point. 1.06. What is the ratio of the Income share held (as % of total income) in First 20% of population in Kazakhstan to that in Lithuania?
Offer a terse response. 1.05. What is the ratio of the Income share held (as % of total income) in Second 20% of population in Kazakhstan to that in Lithuania?
Give a very brief answer. 0.91. What is the ratio of the Income share held (as % of total income) in Third 20% of population in Kazakhstan to that in Lithuania?
Offer a terse response. 0.95. What is the ratio of the Income share held (as % of total income) of Fourth 20% of population in Kazakhstan to that in Lithuania?
Keep it short and to the point. 1.04. What is the ratio of the Income share held (as % of total income) of First 20% of population in Kazakhstan to that in Mexico?
Your answer should be compact. 0.79. What is the ratio of the Income share held (as % of total income) of Second 20% of population in Kazakhstan to that in Mexico?
Your response must be concise. 1.36. What is the ratio of the Income share held (as % of total income) in Third 20% of population in Kazakhstan to that in Mexico?
Provide a succinct answer. 1.24. What is the ratio of the Income share held (as % of total income) of Fourth 20% of population in Kazakhstan to that in Mexico?
Your answer should be compact. 1.15. What is the ratio of the Income share held (as % of total income) in First 20% of population in Latvia to that in Lithuania?
Your response must be concise. 0.98. What is the ratio of the Income share held (as % of total income) of Second 20% of population in Latvia to that in Lithuania?
Make the answer very short. 1.05. What is the ratio of the Income share held (as % of total income) in Third 20% of population in Latvia to that in Lithuania?
Provide a short and direct response. 1.02. What is the ratio of the Income share held (as % of total income) in Fourth 20% of population in Latvia to that in Lithuania?
Your response must be concise. 0.99. What is the ratio of the Income share held (as % of total income) of First 20% of population in Latvia to that in Mexico?
Make the answer very short. 0.74. What is the ratio of the Income share held (as % of total income) in Second 20% of population in Latvia to that in Mexico?
Make the answer very short. 1.56. What is the ratio of the Income share held (as % of total income) in Third 20% of population in Latvia to that in Mexico?
Provide a succinct answer. 1.33. What is the ratio of the Income share held (as % of total income) of Fourth 20% of population in Latvia to that in Mexico?
Your answer should be compact. 1.09. What is the ratio of the Income share held (as % of total income) in First 20% of population in Lithuania to that in Mexico?
Your answer should be very brief. 0.75. What is the ratio of the Income share held (as % of total income) of Second 20% of population in Lithuania to that in Mexico?
Your answer should be very brief. 1.49. What is the ratio of the Income share held (as % of total income) in Third 20% of population in Lithuania to that in Mexico?
Your answer should be compact. 1.3. What is the ratio of the Income share held (as % of total income) in Fourth 20% of population in Lithuania to that in Mexico?
Your response must be concise. 1.1. What is the difference between the highest and the second highest Income share held (as % of total income) of First 20% of population?
Your answer should be compact. 6.41. What is the difference between the highest and the second highest Income share held (as % of total income) of Second 20% of population?
Offer a very short reply. 0.61. What is the difference between the highest and the second highest Income share held (as % of total income) in Third 20% of population?
Offer a terse response. 0.39. What is the difference between the highest and the lowest Income share held (as % of total income) in First 20% of population?
Provide a succinct answer. 14.16. What is the difference between the highest and the lowest Income share held (as % of total income) in Second 20% of population?
Your answer should be very brief. 4.79. What is the difference between the highest and the lowest Income share held (as % of total income) in Third 20% of population?
Give a very brief answer. 4.28. What is the difference between the highest and the lowest Income share held (as % of total income) in Fourth 20% of population?
Offer a very short reply. 2.98. 